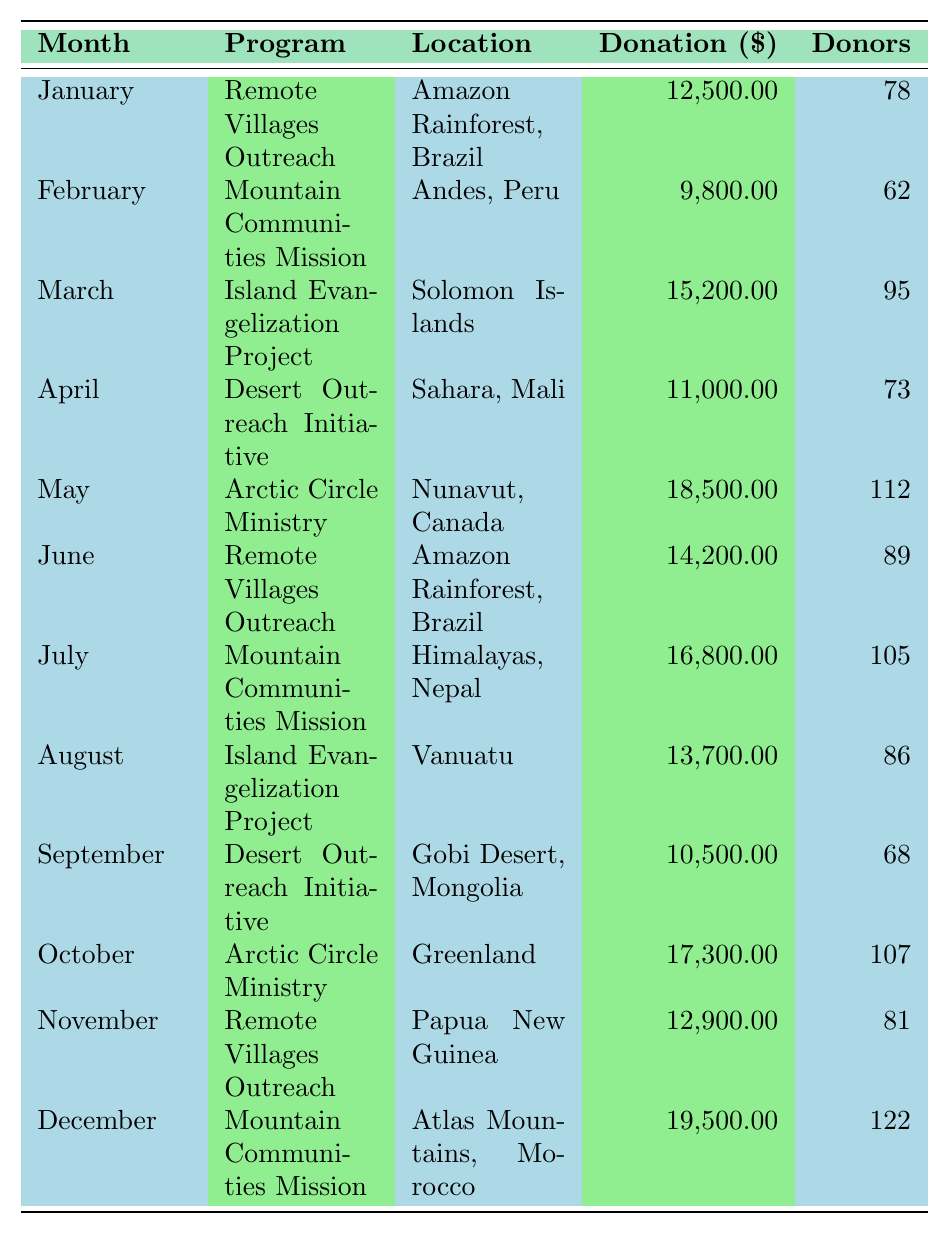What was the total amount donated in May? In May, the table shows that the donation amount for the Arctic Circle Ministry was 18,500.00.
Answer: 18,500.00 Which program received the highest number of donors in December? The Mountain Communities Mission in December had 122 donors, which is the highest number compared to other programs in that month.
Answer: Mountain Communities Mission What was the average donation amount for the Remote Villages Outreach program? The Remote Villages Outreach program has three data points: January (12,500.00), June (14,200.00), and November (12,900.00). To find the average, sum these amounts (12,500 + 14,200 + 12,900 = 39,600) and divide by 3. The average is 39,600 / 3 = 13,200.00.
Answer: 13,200.00 In which month did the Island Evangelization Project receive its highest donation? The Island Evangelization Project received 15,200.00 in March and 13,700.00 in August. March has the higher value.
Answer: March What is the difference in donation amount between the Arctic Circle Ministry in May and October? The Arctic Circle Ministry received 18,500.00 in May and 17,300.00 in October. The difference is calculated as 18,500.00 - 17,300.00 = 1,200.00.
Answer: 1,200.00 How many donors contributed to the Desert Outreach Initiative in total for both April and September? The Desert Outreach Initiative had 73 donors in April and 68 donors in September. Adding these together gives 73 + 68 = 141 donors.
Answer: 141 Does any program receive donations in the same location during different months? Yes, the Remote Villages Outreach program is listed for the Amazon Rainforest, Brazil in January and June.
Answer: Yes What is the month with the lowest total donation amount and how much was it? The lowest donation amount is in February, with 9,800.00 for the Mountain Communities Mission program.
Answer: February, 9,800.00 Which program had the highest total donation amount over the year? The total donations for each program are: Arctic Circle Ministry (35,800.00), Mountain Communities Mission (35,300.00), Island Evangelization Project (28,900.00), Remote Villages Outreach (39,600.00), and Desert Outreach Initiative (21,500.00). The Arctic Circle Ministry has the highest total amount.
Answer: Arctic Circle Ministry What percentage of the total donations in December came from the Mountain Communities Mission? The Mountain Communities Mission received 19,500.00 in December. The total donations for the year sum up to 167,600.00. The percentage is (19,500.00 / 167,600.00) * 100 ≈ 11.63%.
Answer: 11.63% 